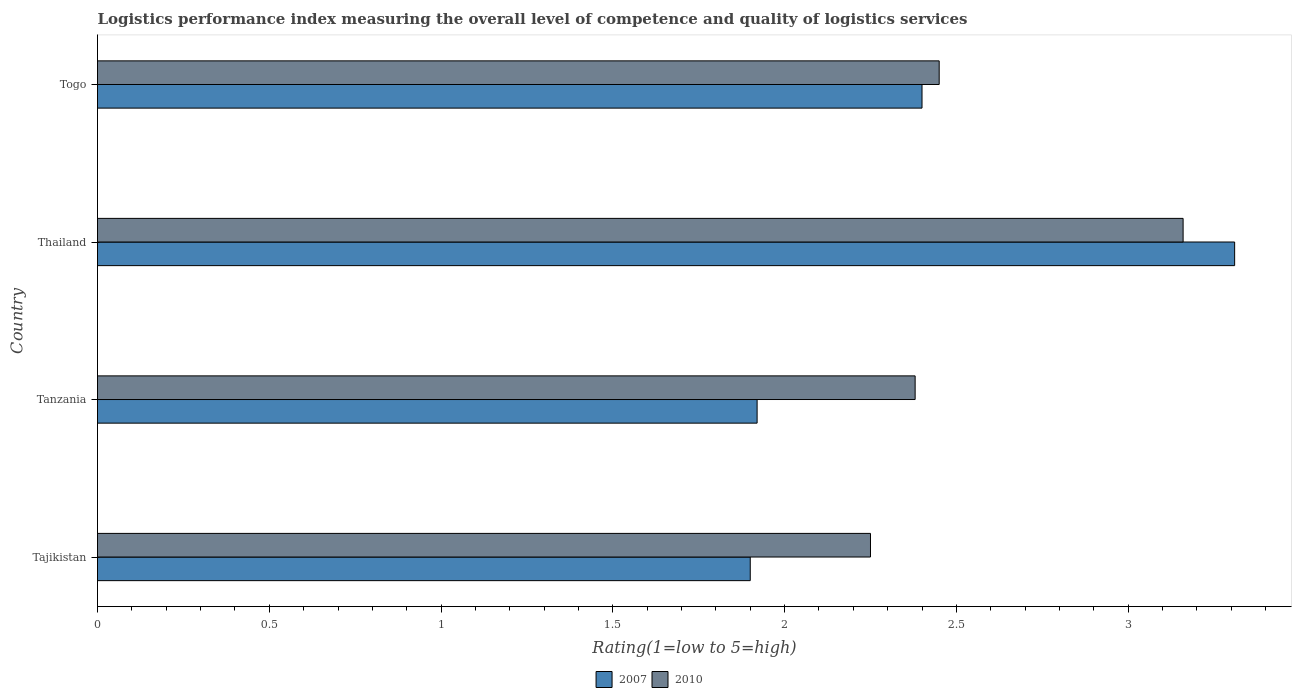Are the number of bars per tick equal to the number of legend labels?
Provide a short and direct response. Yes. How many bars are there on the 2nd tick from the top?
Your answer should be compact. 2. What is the label of the 4th group of bars from the top?
Keep it short and to the point. Tajikistan. In how many cases, is the number of bars for a given country not equal to the number of legend labels?
Ensure brevity in your answer.  0. What is the Logistic performance index in 2010 in Togo?
Your answer should be compact. 2.45. Across all countries, what is the maximum Logistic performance index in 2010?
Offer a very short reply. 3.16. In which country was the Logistic performance index in 2007 maximum?
Ensure brevity in your answer.  Thailand. In which country was the Logistic performance index in 2010 minimum?
Offer a very short reply. Tajikistan. What is the total Logistic performance index in 2010 in the graph?
Your response must be concise. 10.24. What is the difference between the Logistic performance index in 2010 in Tanzania and that in Thailand?
Offer a terse response. -0.78. What is the difference between the Logistic performance index in 2007 in Tajikistan and the Logistic performance index in 2010 in Togo?
Your response must be concise. -0.55. What is the average Logistic performance index in 2007 per country?
Provide a succinct answer. 2.38. What is the difference between the Logistic performance index in 2010 and Logistic performance index in 2007 in Togo?
Your answer should be compact. 0.05. What is the ratio of the Logistic performance index in 2010 in Tajikistan to that in Thailand?
Ensure brevity in your answer.  0.71. Is the Logistic performance index in 2007 in Thailand less than that in Togo?
Offer a very short reply. No. Is the difference between the Logistic performance index in 2010 in Thailand and Togo greater than the difference between the Logistic performance index in 2007 in Thailand and Togo?
Your response must be concise. No. What is the difference between the highest and the second highest Logistic performance index in 2007?
Your response must be concise. 0.91. What is the difference between the highest and the lowest Logistic performance index in 2010?
Offer a very short reply. 0.91. In how many countries, is the Logistic performance index in 2010 greater than the average Logistic performance index in 2010 taken over all countries?
Offer a terse response. 1. Is the sum of the Logistic performance index in 2007 in Tajikistan and Togo greater than the maximum Logistic performance index in 2010 across all countries?
Your answer should be very brief. Yes. What does the 2nd bar from the top in Togo represents?
Ensure brevity in your answer.  2007. What does the 2nd bar from the bottom in Thailand represents?
Make the answer very short. 2010. How many countries are there in the graph?
Make the answer very short. 4. Does the graph contain any zero values?
Your answer should be compact. No. Does the graph contain grids?
Offer a very short reply. No. How are the legend labels stacked?
Make the answer very short. Horizontal. What is the title of the graph?
Your answer should be compact. Logistics performance index measuring the overall level of competence and quality of logistics services. Does "1993" appear as one of the legend labels in the graph?
Provide a short and direct response. No. What is the label or title of the X-axis?
Ensure brevity in your answer.  Rating(1=low to 5=high). What is the label or title of the Y-axis?
Keep it short and to the point. Country. What is the Rating(1=low to 5=high) in 2007 in Tajikistan?
Your answer should be compact. 1.9. What is the Rating(1=low to 5=high) of 2010 in Tajikistan?
Offer a terse response. 2.25. What is the Rating(1=low to 5=high) of 2007 in Tanzania?
Provide a succinct answer. 1.92. What is the Rating(1=low to 5=high) of 2010 in Tanzania?
Your answer should be very brief. 2.38. What is the Rating(1=low to 5=high) in 2007 in Thailand?
Your answer should be very brief. 3.31. What is the Rating(1=low to 5=high) in 2010 in Thailand?
Your answer should be very brief. 3.16. What is the Rating(1=low to 5=high) of 2007 in Togo?
Offer a very short reply. 2.4. What is the Rating(1=low to 5=high) of 2010 in Togo?
Provide a succinct answer. 2.45. Across all countries, what is the maximum Rating(1=low to 5=high) in 2007?
Give a very brief answer. 3.31. Across all countries, what is the maximum Rating(1=low to 5=high) of 2010?
Your answer should be very brief. 3.16. Across all countries, what is the minimum Rating(1=low to 5=high) in 2010?
Make the answer very short. 2.25. What is the total Rating(1=low to 5=high) in 2007 in the graph?
Offer a very short reply. 9.53. What is the total Rating(1=low to 5=high) in 2010 in the graph?
Provide a succinct answer. 10.24. What is the difference between the Rating(1=low to 5=high) in 2007 in Tajikistan and that in Tanzania?
Your response must be concise. -0.02. What is the difference between the Rating(1=low to 5=high) of 2010 in Tajikistan and that in Tanzania?
Provide a short and direct response. -0.13. What is the difference between the Rating(1=low to 5=high) of 2007 in Tajikistan and that in Thailand?
Your response must be concise. -1.41. What is the difference between the Rating(1=low to 5=high) of 2010 in Tajikistan and that in Thailand?
Ensure brevity in your answer.  -0.91. What is the difference between the Rating(1=low to 5=high) of 2010 in Tajikistan and that in Togo?
Provide a short and direct response. -0.2. What is the difference between the Rating(1=low to 5=high) of 2007 in Tanzania and that in Thailand?
Provide a succinct answer. -1.39. What is the difference between the Rating(1=low to 5=high) of 2010 in Tanzania and that in Thailand?
Offer a terse response. -0.78. What is the difference between the Rating(1=low to 5=high) of 2007 in Tanzania and that in Togo?
Make the answer very short. -0.48. What is the difference between the Rating(1=low to 5=high) in 2010 in Tanzania and that in Togo?
Give a very brief answer. -0.07. What is the difference between the Rating(1=low to 5=high) of 2007 in Thailand and that in Togo?
Give a very brief answer. 0.91. What is the difference between the Rating(1=low to 5=high) of 2010 in Thailand and that in Togo?
Provide a succinct answer. 0.71. What is the difference between the Rating(1=low to 5=high) in 2007 in Tajikistan and the Rating(1=low to 5=high) in 2010 in Tanzania?
Make the answer very short. -0.48. What is the difference between the Rating(1=low to 5=high) of 2007 in Tajikistan and the Rating(1=low to 5=high) of 2010 in Thailand?
Offer a very short reply. -1.26. What is the difference between the Rating(1=low to 5=high) in 2007 in Tajikistan and the Rating(1=low to 5=high) in 2010 in Togo?
Ensure brevity in your answer.  -0.55. What is the difference between the Rating(1=low to 5=high) in 2007 in Tanzania and the Rating(1=low to 5=high) in 2010 in Thailand?
Ensure brevity in your answer.  -1.24. What is the difference between the Rating(1=low to 5=high) in 2007 in Tanzania and the Rating(1=low to 5=high) in 2010 in Togo?
Give a very brief answer. -0.53. What is the difference between the Rating(1=low to 5=high) of 2007 in Thailand and the Rating(1=low to 5=high) of 2010 in Togo?
Your answer should be compact. 0.86. What is the average Rating(1=low to 5=high) of 2007 per country?
Your answer should be compact. 2.38. What is the average Rating(1=low to 5=high) in 2010 per country?
Offer a very short reply. 2.56. What is the difference between the Rating(1=low to 5=high) of 2007 and Rating(1=low to 5=high) of 2010 in Tajikistan?
Provide a short and direct response. -0.35. What is the difference between the Rating(1=low to 5=high) in 2007 and Rating(1=low to 5=high) in 2010 in Tanzania?
Make the answer very short. -0.46. What is the ratio of the Rating(1=low to 5=high) in 2007 in Tajikistan to that in Tanzania?
Your answer should be compact. 0.99. What is the ratio of the Rating(1=low to 5=high) in 2010 in Tajikistan to that in Tanzania?
Provide a succinct answer. 0.95. What is the ratio of the Rating(1=low to 5=high) in 2007 in Tajikistan to that in Thailand?
Ensure brevity in your answer.  0.57. What is the ratio of the Rating(1=low to 5=high) in 2010 in Tajikistan to that in Thailand?
Ensure brevity in your answer.  0.71. What is the ratio of the Rating(1=low to 5=high) in 2007 in Tajikistan to that in Togo?
Provide a succinct answer. 0.79. What is the ratio of the Rating(1=low to 5=high) in 2010 in Tajikistan to that in Togo?
Your answer should be compact. 0.92. What is the ratio of the Rating(1=low to 5=high) in 2007 in Tanzania to that in Thailand?
Keep it short and to the point. 0.58. What is the ratio of the Rating(1=low to 5=high) in 2010 in Tanzania to that in Thailand?
Offer a terse response. 0.75. What is the ratio of the Rating(1=low to 5=high) in 2007 in Tanzania to that in Togo?
Provide a succinct answer. 0.8. What is the ratio of the Rating(1=low to 5=high) of 2010 in Tanzania to that in Togo?
Offer a very short reply. 0.97. What is the ratio of the Rating(1=low to 5=high) of 2007 in Thailand to that in Togo?
Your answer should be very brief. 1.38. What is the ratio of the Rating(1=low to 5=high) of 2010 in Thailand to that in Togo?
Provide a succinct answer. 1.29. What is the difference between the highest and the second highest Rating(1=low to 5=high) in 2007?
Give a very brief answer. 0.91. What is the difference between the highest and the second highest Rating(1=low to 5=high) in 2010?
Give a very brief answer. 0.71. What is the difference between the highest and the lowest Rating(1=low to 5=high) in 2007?
Make the answer very short. 1.41. What is the difference between the highest and the lowest Rating(1=low to 5=high) of 2010?
Keep it short and to the point. 0.91. 